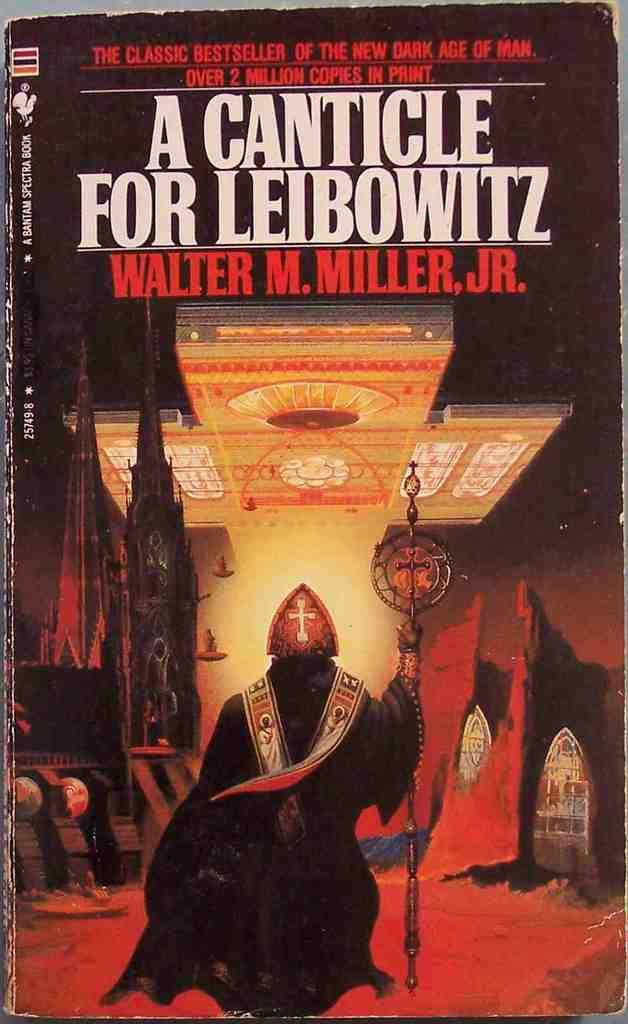<image>
Write a terse but informative summary of the picture. A book titled A Canticle for Leaibowitz wrtten by Walter M Miller Jr. 